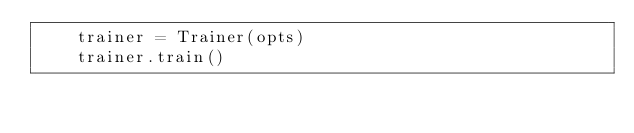<code> <loc_0><loc_0><loc_500><loc_500><_Python_>    trainer = Trainer(opts)
    trainer.train()
</code> 